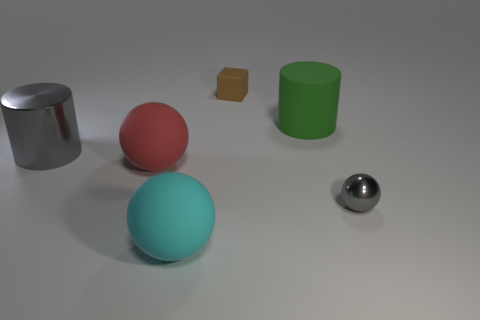What number of other objects are the same color as the metallic ball?
Provide a short and direct response. 1. Does the small shiny ball have the same color as the rubber cube?
Offer a very short reply. No. What size is the green thing that is the same shape as the big gray object?
Your response must be concise. Large. What number of gray cylinders are the same material as the gray ball?
Keep it short and to the point. 1. Are the cylinder that is left of the large cyan matte sphere and the red ball made of the same material?
Offer a terse response. No. Is the number of brown rubber objects behind the big shiny cylinder the same as the number of cyan metal spheres?
Make the answer very short. No. What size is the gray ball?
Keep it short and to the point. Small. There is another thing that is the same color as the tiny metallic thing; what is its material?
Provide a succinct answer. Metal. What number of metal cylinders have the same color as the small sphere?
Keep it short and to the point. 1. Is the rubber block the same size as the gray cylinder?
Provide a succinct answer. No. 